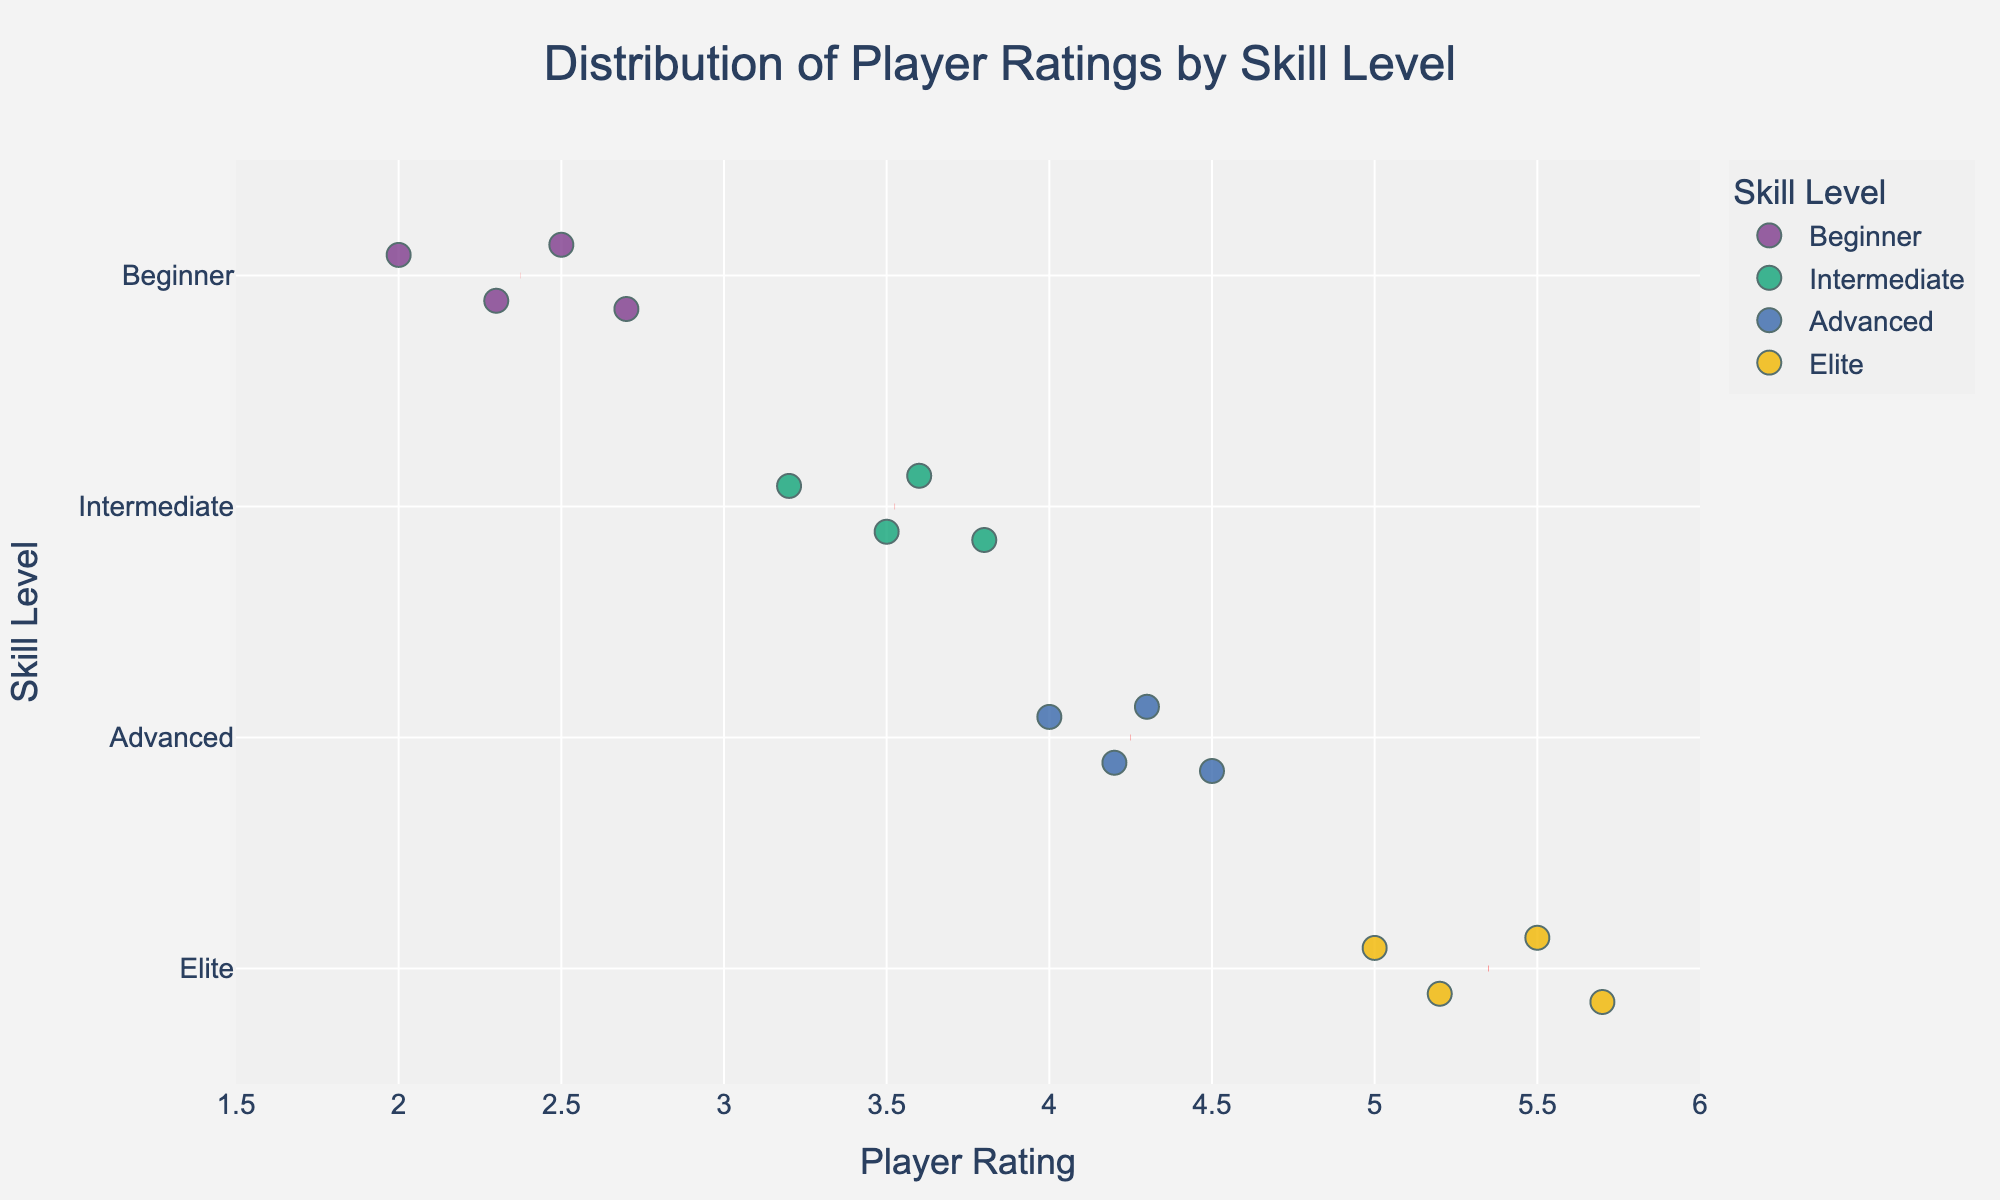What's the title of the figure? The title is usually displayed at the top of the figure, it provides a summary of what the figure represents.
Answer: Distribution of Player Ratings by Skill Level What are the skill levels represented on the y-axis? The y-axis categories are visible along the vertical axis and show different skill levels.
Answer: Beginner, Intermediate, Advanced, Elite What is the range of player ratings on the x-axis? The x-axis range can be seen along the horizontal axis; it shows the span of player ratings.
Answer: 1.5 to 6 Which color represents the Intermediate skill level? The color coding for each skill level is shown in the figure legend or directly on the plot itself.
Answer: (Look at the color representing 'Intermediate' category in the plot) How many players belong to the Elite skill level? Each individual marker represents a player; count the markers for the 'Elite' category.
Answer: 4 What's the mean rating for the Adult skill level? Locate the mean value marker (red dashed line) for the 'Intermediate' skill level on the x-axis.
Answer: 3.525 Which skill level has the widest range of ratings? Determine the range by identifying the maximum and minimum ratings for each skill level and compare to see which one has the largest spread.
Answer: Elite Who's the highest rated player and what's their score? Hover over the markers to see which player has the highest rating and check the hover information.
Answer: Emily Taylor with a rating of 5.7 Compare the average ratings for Beginner and Intermediate levels. Which one is higher? Calculate the mean ratings for both levels (use the provided mean lines), and then compare them.
Answer: Intermediate What is the skill level of a player with a rating of 4.2? Find the x-axis value of 4.2 and see where it aligns with the corresponding skill level on the y-axis.
Answer: Advanced 